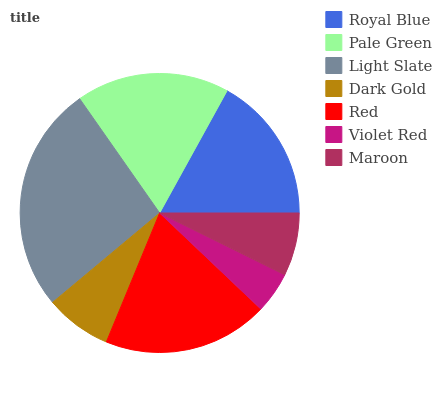Is Violet Red the minimum?
Answer yes or no. Yes. Is Light Slate the maximum?
Answer yes or no. Yes. Is Pale Green the minimum?
Answer yes or no. No. Is Pale Green the maximum?
Answer yes or no. No. Is Pale Green greater than Royal Blue?
Answer yes or no. Yes. Is Royal Blue less than Pale Green?
Answer yes or no. Yes. Is Royal Blue greater than Pale Green?
Answer yes or no. No. Is Pale Green less than Royal Blue?
Answer yes or no. No. Is Royal Blue the high median?
Answer yes or no. Yes. Is Royal Blue the low median?
Answer yes or no. Yes. Is Maroon the high median?
Answer yes or no. No. Is Maroon the low median?
Answer yes or no. No. 